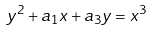<formula> <loc_0><loc_0><loc_500><loc_500>y ^ { 2 } + a _ { 1 } x + a _ { 3 } y = x ^ { 3 }</formula> 